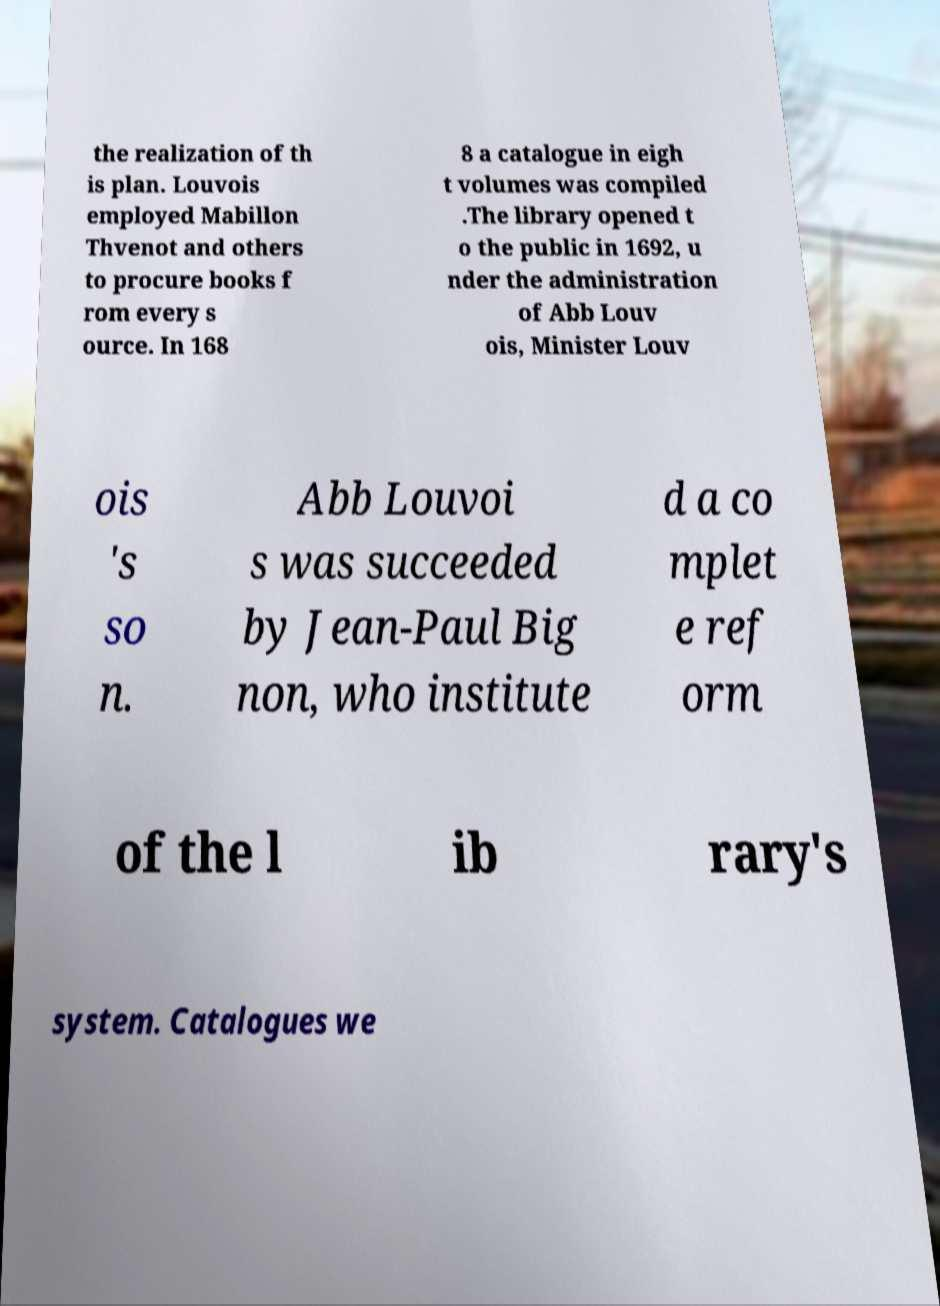What messages or text are displayed in this image? I need them in a readable, typed format. the realization of th is plan. Louvois employed Mabillon Thvenot and others to procure books f rom every s ource. In 168 8 a catalogue in eigh t volumes was compiled .The library opened t o the public in 1692, u nder the administration of Abb Louv ois, Minister Louv ois 's so n. Abb Louvoi s was succeeded by Jean-Paul Big non, who institute d a co mplet e ref orm of the l ib rary's system. Catalogues we 